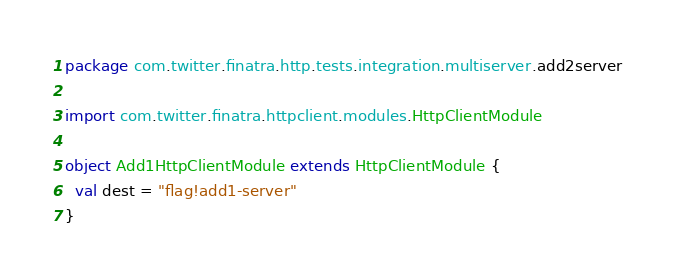Convert code to text. <code><loc_0><loc_0><loc_500><loc_500><_Scala_>package com.twitter.finatra.http.tests.integration.multiserver.add2server

import com.twitter.finatra.httpclient.modules.HttpClientModule

object Add1HttpClientModule extends HttpClientModule {
  val dest = "flag!add1-server"
}
</code> 